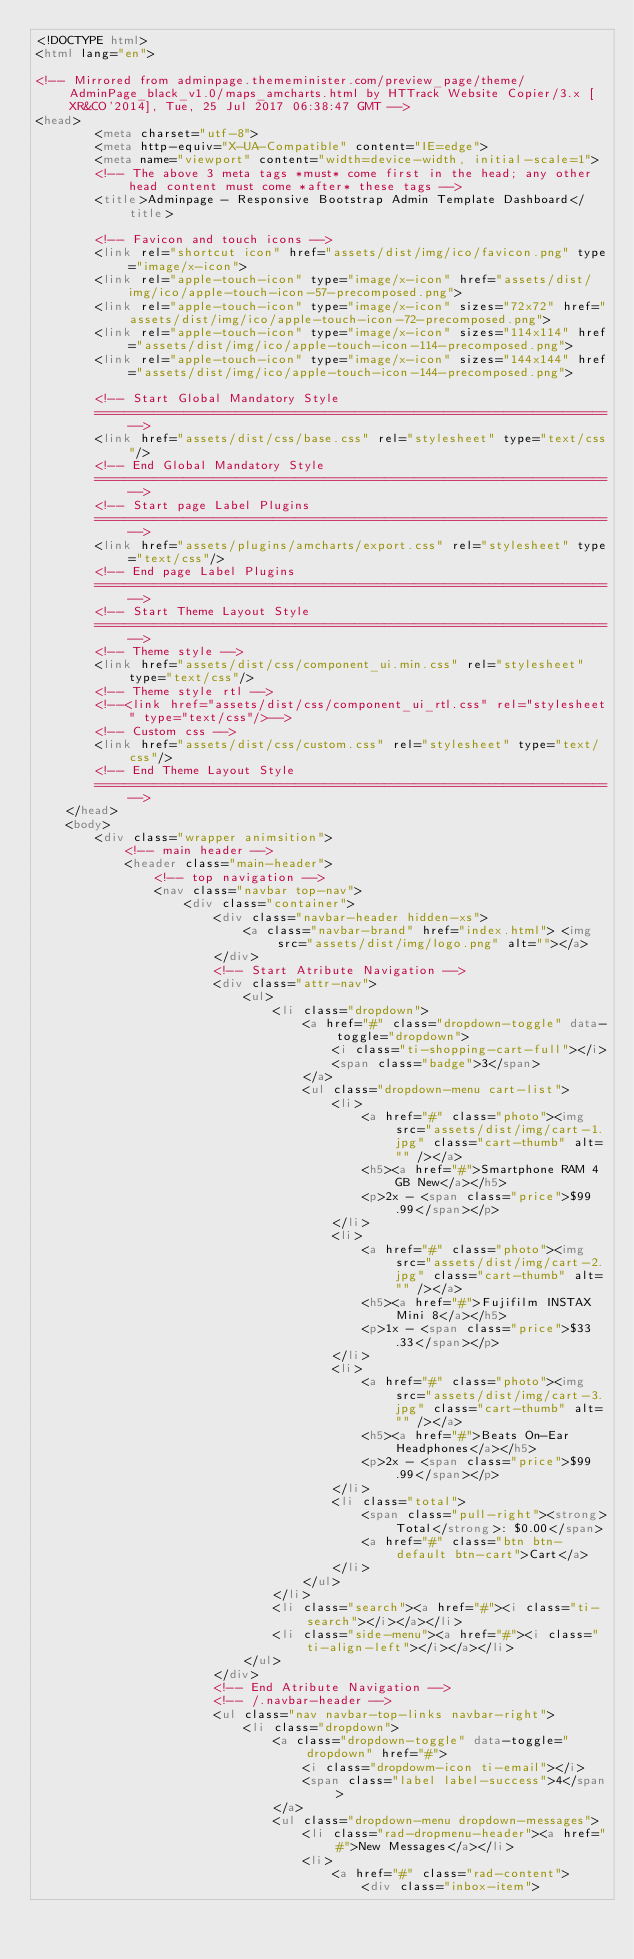Convert code to text. <code><loc_0><loc_0><loc_500><loc_500><_HTML_><!DOCTYPE html>
<html lang="en">
    
<!-- Mirrored from adminpage.thememinister.com/preview_page/theme/AdminPage_black_v1.0/maps_amcharts.html by HTTrack Website Copier/3.x [XR&CO'2014], Tue, 25 Jul 2017 06:38:47 GMT -->
<head>
        <meta charset="utf-8">
        <meta http-equiv="X-UA-Compatible" content="IE=edge">
        <meta name="viewport" content="width=device-width, initial-scale=1">
        <!-- The above 3 meta tags *must* come first in the head; any other head content must come *after* these tags -->
        <title>Adminpage - Responsive Bootstrap Admin Template Dashboard</title>

        <!-- Favicon and touch icons -->
        <link rel="shortcut icon" href="assets/dist/img/ico/favicon.png" type="image/x-icon">
        <link rel="apple-touch-icon" type="image/x-icon" href="assets/dist/img/ico/apple-touch-icon-57-precomposed.png">
        <link rel="apple-touch-icon" type="image/x-icon" sizes="72x72" href="assets/dist/img/ico/apple-touch-icon-72-precomposed.png">
        <link rel="apple-touch-icon" type="image/x-icon" sizes="114x114" href="assets/dist/img/ico/apple-touch-icon-114-precomposed.png">
        <link rel="apple-touch-icon" type="image/x-icon" sizes="144x144" href="assets/dist/img/ico/apple-touch-icon-144-precomposed.png">

        <!-- Start Global Mandatory Style
        =====================================================================-->
        <link href="assets/dist/css/base.css" rel="stylesheet" type="text/css"/>
        <!-- End Global Mandatory Style
        =====================================================================-->
        <!-- Start page Label Plugins 
        =====================================================================-->
        <link href="assets/plugins/amcharts/export.css" rel="stylesheet" type="text/css"/>
        <!-- End page Label Plugins 
        =====================================================================-->
        <!-- Start Theme Layout Style
        =====================================================================-->
        <!-- Theme style -->
        <link href="assets/dist/css/component_ui.min.css" rel="stylesheet" type="text/css"/>
        <!-- Theme style rtl -->
        <!--<link href="assets/dist/css/component_ui_rtl.css" rel="stylesheet" type="text/css"/>-->
        <!-- Custom css -->
        <link href="assets/dist/css/custom.css" rel="stylesheet" type="text/css"/>
        <!-- End Theme Layout Style
        =====================================================================-->
    </head>
    <body>
        <div class="wrapper animsition">
            <!-- main header -->
            <header class="main-header">
                <!-- top navigation -->
                <nav class="navbar top-nav">
                    <div class="container">
                        <div class="navbar-header hidden-xs">
                            <a class="navbar-brand" href="index.html"> <img src="assets/dist/img/logo.png" alt=""></a>
                        </div>
                        <!-- Start Atribute Navigation -->
                        <div class="attr-nav">
                            <ul>
                                <li class="dropdown">
                                    <a href="#" class="dropdown-toggle" data-toggle="dropdown">
                                        <i class="ti-shopping-cart-full"></i>
                                        <span class="badge">3</span>
                                    </a>
                                    <ul class="dropdown-menu cart-list">
                                        <li>
                                            <a href="#" class="photo"><img src="assets/dist/img/cart-1.jpg" class="cart-thumb" alt="" /></a>
                                            <h5><a href="#">Smartphone RAM 4 GB New</a></h5>
                                            <p>2x - <span class="price">$99.99</span></p>
                                        </li>
                                        <li>
                                            <a href="#" class="photo"><img src="assets/dist/img/cart-2.jpg" class="cart-thumb" alt="" /></a>
                                            <h5><a href="#">Fujifilm INSTAX Mini 8</a></h5>
                                            <p>1x - <span class="price">$33.33</span></p>
                                        </li>
                                        <li>
                                            <a href="#" class="photo"><img src="assets/dist/img/cart-3.jpg" class="cart-thumb" alt="" /></a>
                                            <h5><a href="#">Beats On-Ear Headphones</a></h5>
                                            <p>2x - <span class="price">$99.99</span></p>
                                        </li>
                                        <li class="total">
                                            <span class="pull-right"><strong>Total</strong>: $0.00</span>
                                            <a href="#" class="btn btn-default btn-cart">Cart</a>
                                        </li>
                                    </ul>
                                </li>
                                <li class="search"><a href="#"><i class="ti-search"></i></a></li>
                                <li class="side-menu"><a href="#"><i class="ti-align-left"></i></a></li>
                            </ul>
                        </div>
                        <!-- End Atribute Navigation -->
                        <!-- /.navbar-header -->
                        <ul class="nav navbar-top-links navbar-right">
                            <li class="dropdown">
                                <a class="dropdown-toggle" data-toggle="dropdown" href="#">
                                    <i class="dropdowm-icon ti-email"></i>
                                    <span class="label label-success">4</span>
                                </a>
                                <ul class="dropdown-menu dropdown-messages">
                                    <li class="rad-dropmenu-header"><a href="#">New Messages</a></li>
                                    <li>
                                        <a href="#" class="rad-content">
                                            <div class="inbox-item"></code> 